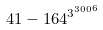<formula> <loc_0><loc_0><loc_500><loc_500>4 1 - 1 6 4 ^ { { 3 ^ { 3 0 0 } } ^ { 6 } }</formula> 